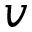<formula> <loc_0><loc_0><loc_500><loc_500>v</formula> 